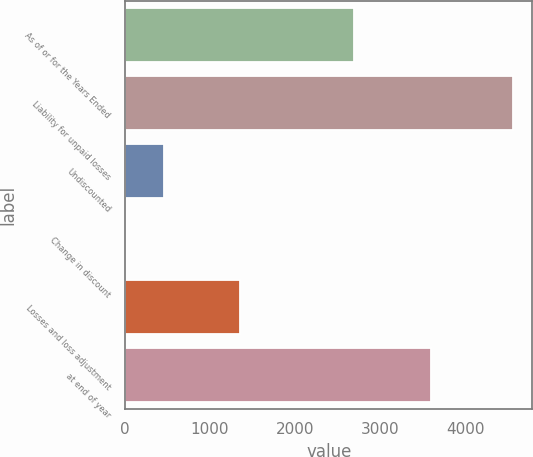<chart> <loc_0><loc_0><loc_500><loc_500><bar_chart><fcel>As of or for the Years Ended<fcel>Liability for unpaid losses<fcel>Undiscounted<fcel>Change in discount<fcel>Losses and loss adjustment<fcel>at end of year<nl><fcel>2694.6<fcel>4564.6<fcel>456.6<fcel>9<fcel>1351.8<fcel>3595<nl></chart> 